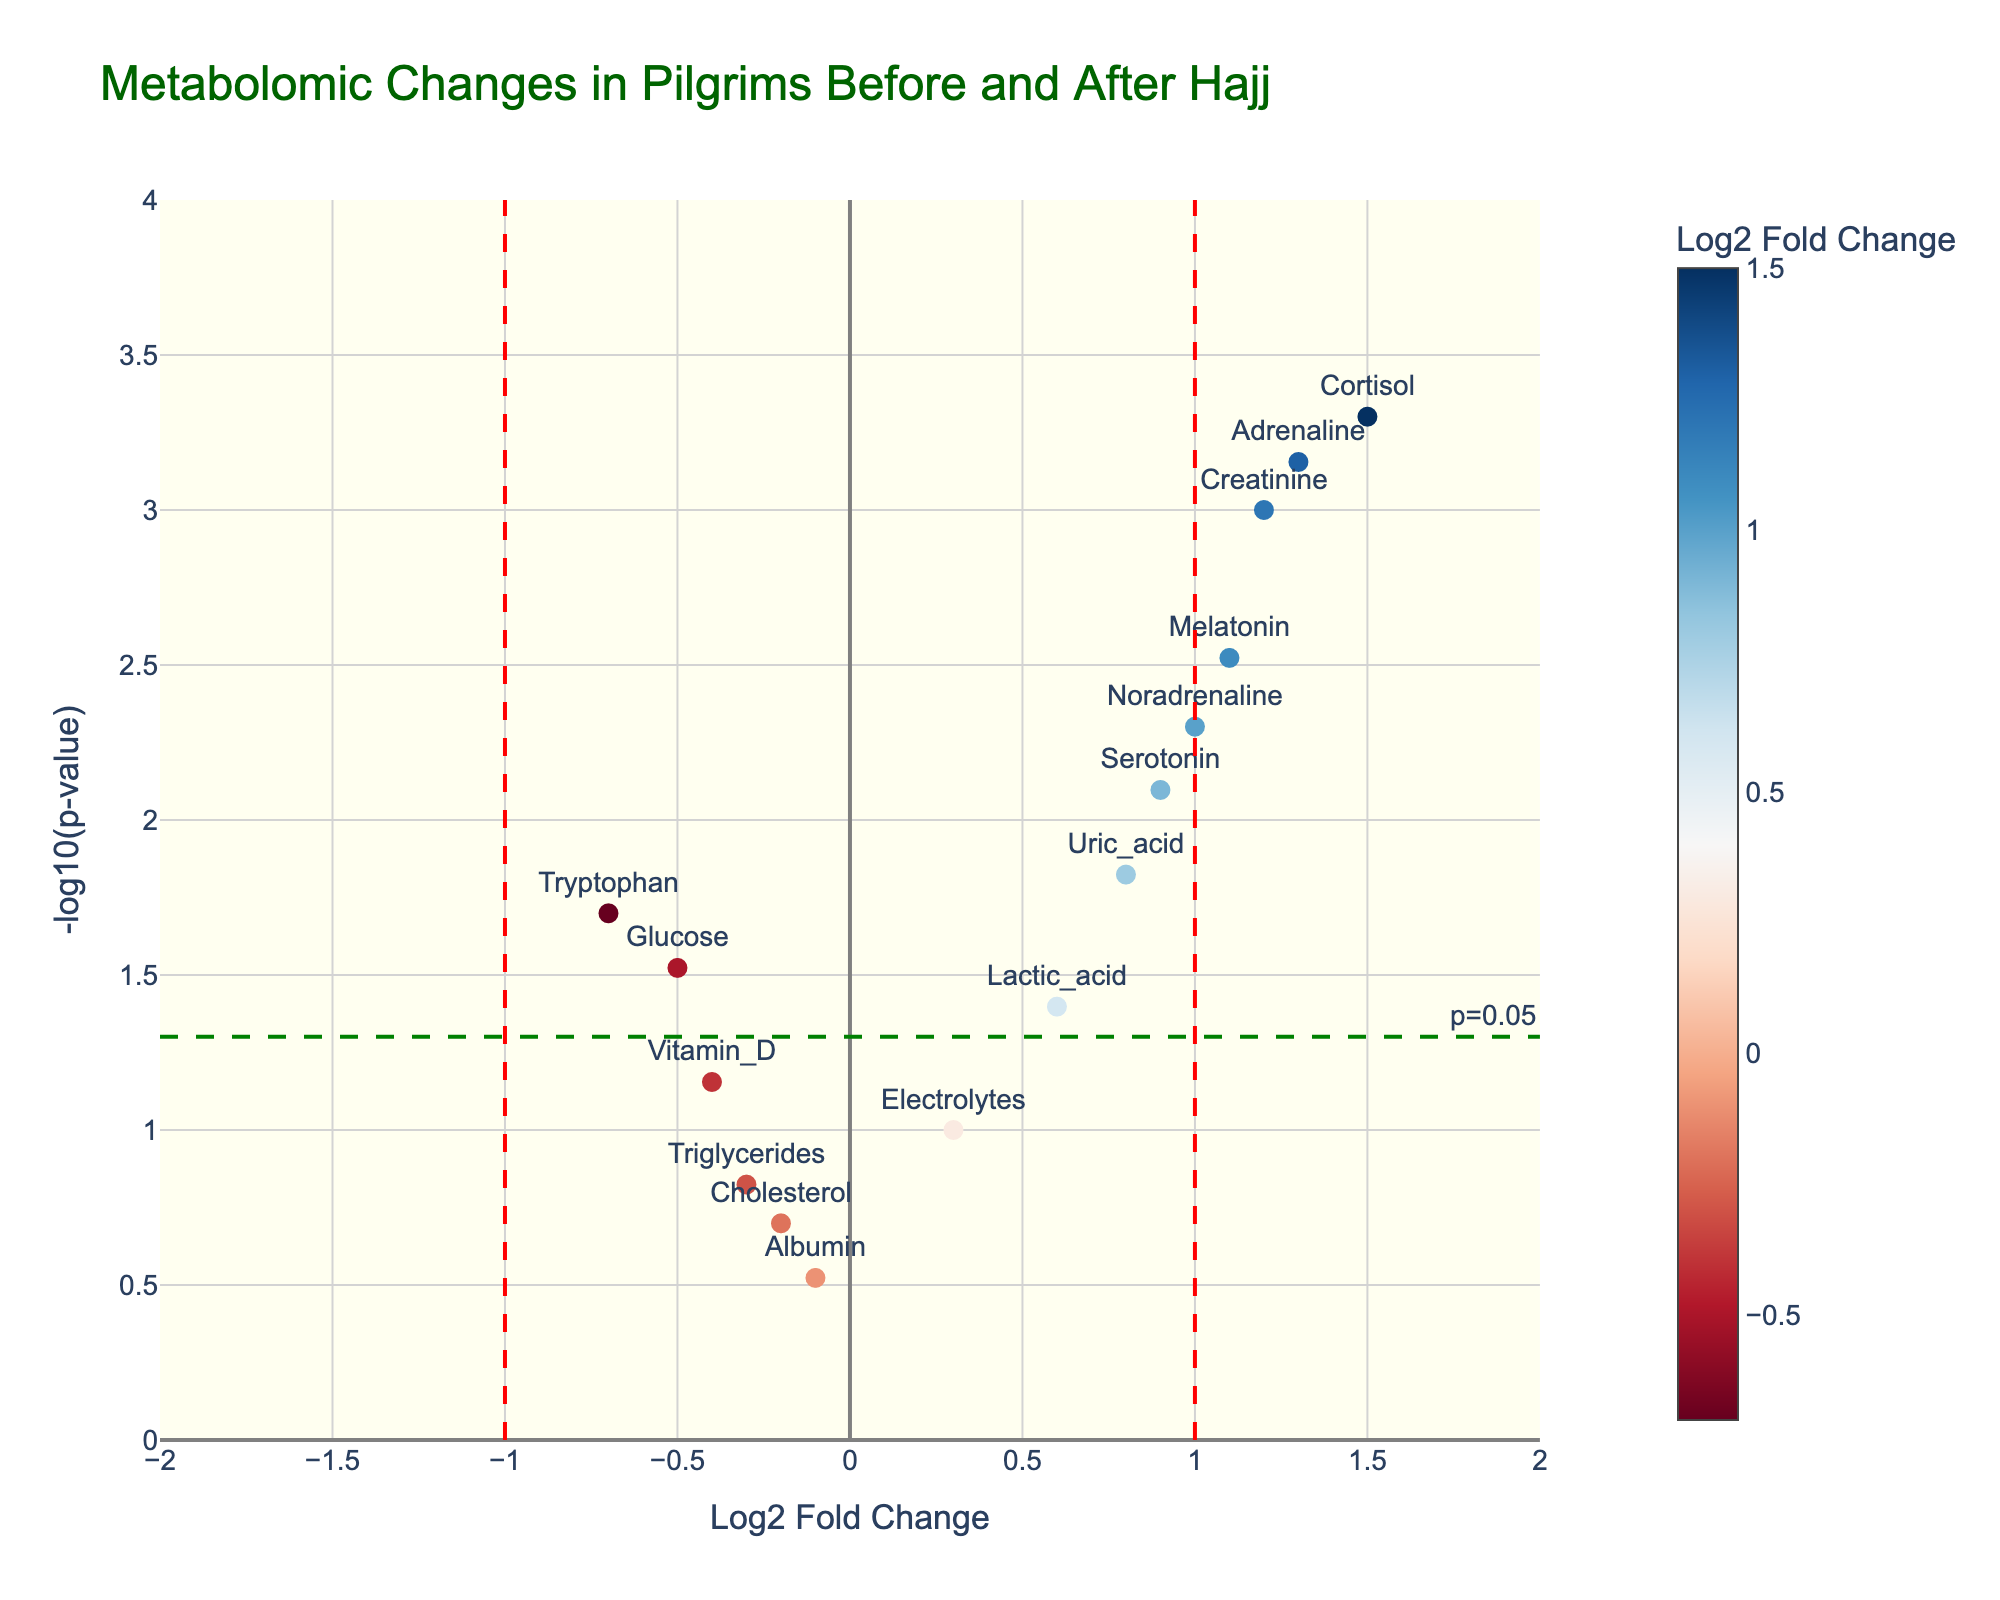What is the title of the plot? The title is usually displayed at the top of the plot and directly states its name.
Answer: Metabolomic Changes in Pilgrims Before and After Hajj What do the x-axis and y-axis represent? The x-axis is labeled "Log2 Fold Change" which represents the logarithm (base 2) of fold changes, and the y-axis is labeled "-log10(p-value)" which represents the negative logarithm (base 10) of the p-value.
Answer: Log2 Fold Change and -log10(p-value) How many metabolites have a p-value less than 0.05? To determine this, we need to count the points above the green horizontal line, as a -log10(p-value) above 1.3 corresponds to a p-value below 0.05.
Answer: 9 Which metabolite has the highest Log2 Fold Change? The highest Log2 Fold Change will be the point farthest to the right on the x-axis. The marker also likely has the largest positive number.
Answer: Cortisol What does the red vertical line at x = 1 represent? This line represents the Log2 Fold Change threshold of 1, indicating a significant increase in metabolite levels.
Answer: Significant positive fold change Which metabolites are significantly downregulated (Log2 Fold Change < -1) with a p-value < 0.05? No points have a Log2 Fold Change less than -1, as there are no points to the far left of -1 and above the green p-value threshold line.
Answer: None What color scale is used to represent the Log2 Fold Change? The color scale ranges from blue to red, with the bar indicating this next to the plot. Blue is for negative values and red for positive values, showing different levels of Log2 Fold Change.
Answer: RdBu Which metabolite has a notable increase in both Log2 Fold Change and significance (highest on y-axis)? The most significant metabolite is at the top of the y-axis with the highest negative log10(p-value) and an increased Log2 Fold Change.
Answer: Cortisol 